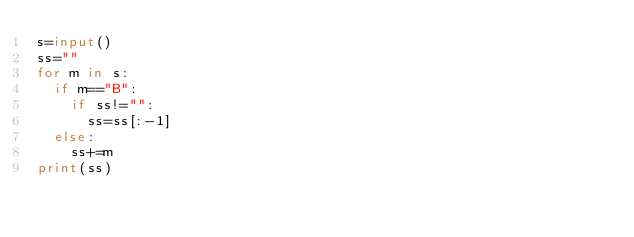<code> <loc_0><loc_0><loc_500><loc_500><_Python_>s=input()
ss=""
for m in s:
  if m=="B":
    if ss!="":
      ss=ss[:-1]
  else:
    ss+=m
print(ss)
      </code> 